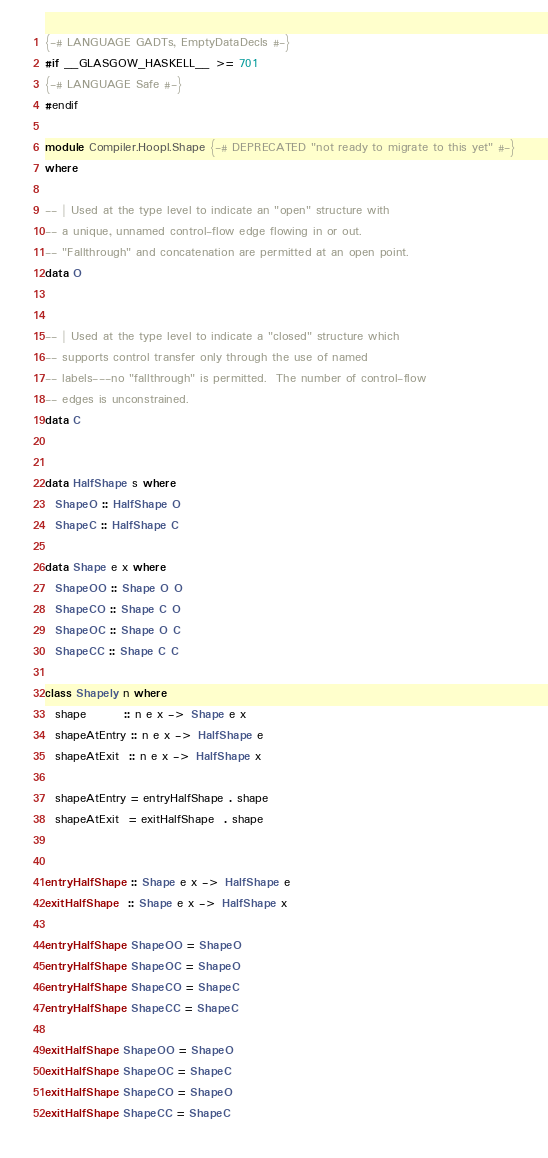<code> <loc_0><loc_0><loc_500><loc_500><_Haskell_>{-# LANGUAGE GADTs, EmptyDataDecls #-}
#if __GLASGOW_HASKELL__ >= 701
{-# LANGUAGE Safe #-}
#endif

module Compiler.Hoopl.Shape {-# DEPRECATED "not ready to migrate to this yet" #-}
where

-- | Used at the type level to indicate an "open" structure with    
-- a unique, unnamed control-flow edge flowing in or out.         
-- "Fallthrough" and concatenation are permitted at an open point.
data O 
       
       
-- | Used at the type level to indicate a "closed" structure which
-- supports control transfer only through the use of named
-- labels---no "fallthrough" is permitted.  The number of control-flow
-- edges is unconstrained.
data C


data HalfShape s where
  ShapeO :: HalfShape O
  ShapeC :: HalfShape C

data Shape e x where
  ShapeOO :: Shape O O
  ShapeCO :: Shape C O
  ShapeOC :: Shape O C
  ShapeCC :: Shape C C

class Shapely n where
  shape        :: n e x -> Shape e x
  shapeAtEntry :: n e x -> HalfShape e
  shapeAtExit  :: n e x -> HalfShape x

  shapeAtEntry = entryHalfShape . shape
  shapeAtExit  = exitHalfShape  . shape
  

entryHalfShape :: Shape e x -> HalfShape e
exitHalfShape  :: Shape e x -> HalfShape x

entryHalfShape ShapeOO = ShapeO
entryHalfShape ShapeOC = ShapeO
entryHalfShape ShapeCO = ShapeC
entryHalfShape ShapeCC = ShapeC

exitHalfShape ShapeOO = ShapeO
exitHalfShape ShapeOC = ShapeC
exitHalfShape ShapeCO = ShapeO
exitHalfShape ShapeCC = ShapeC

</code> 